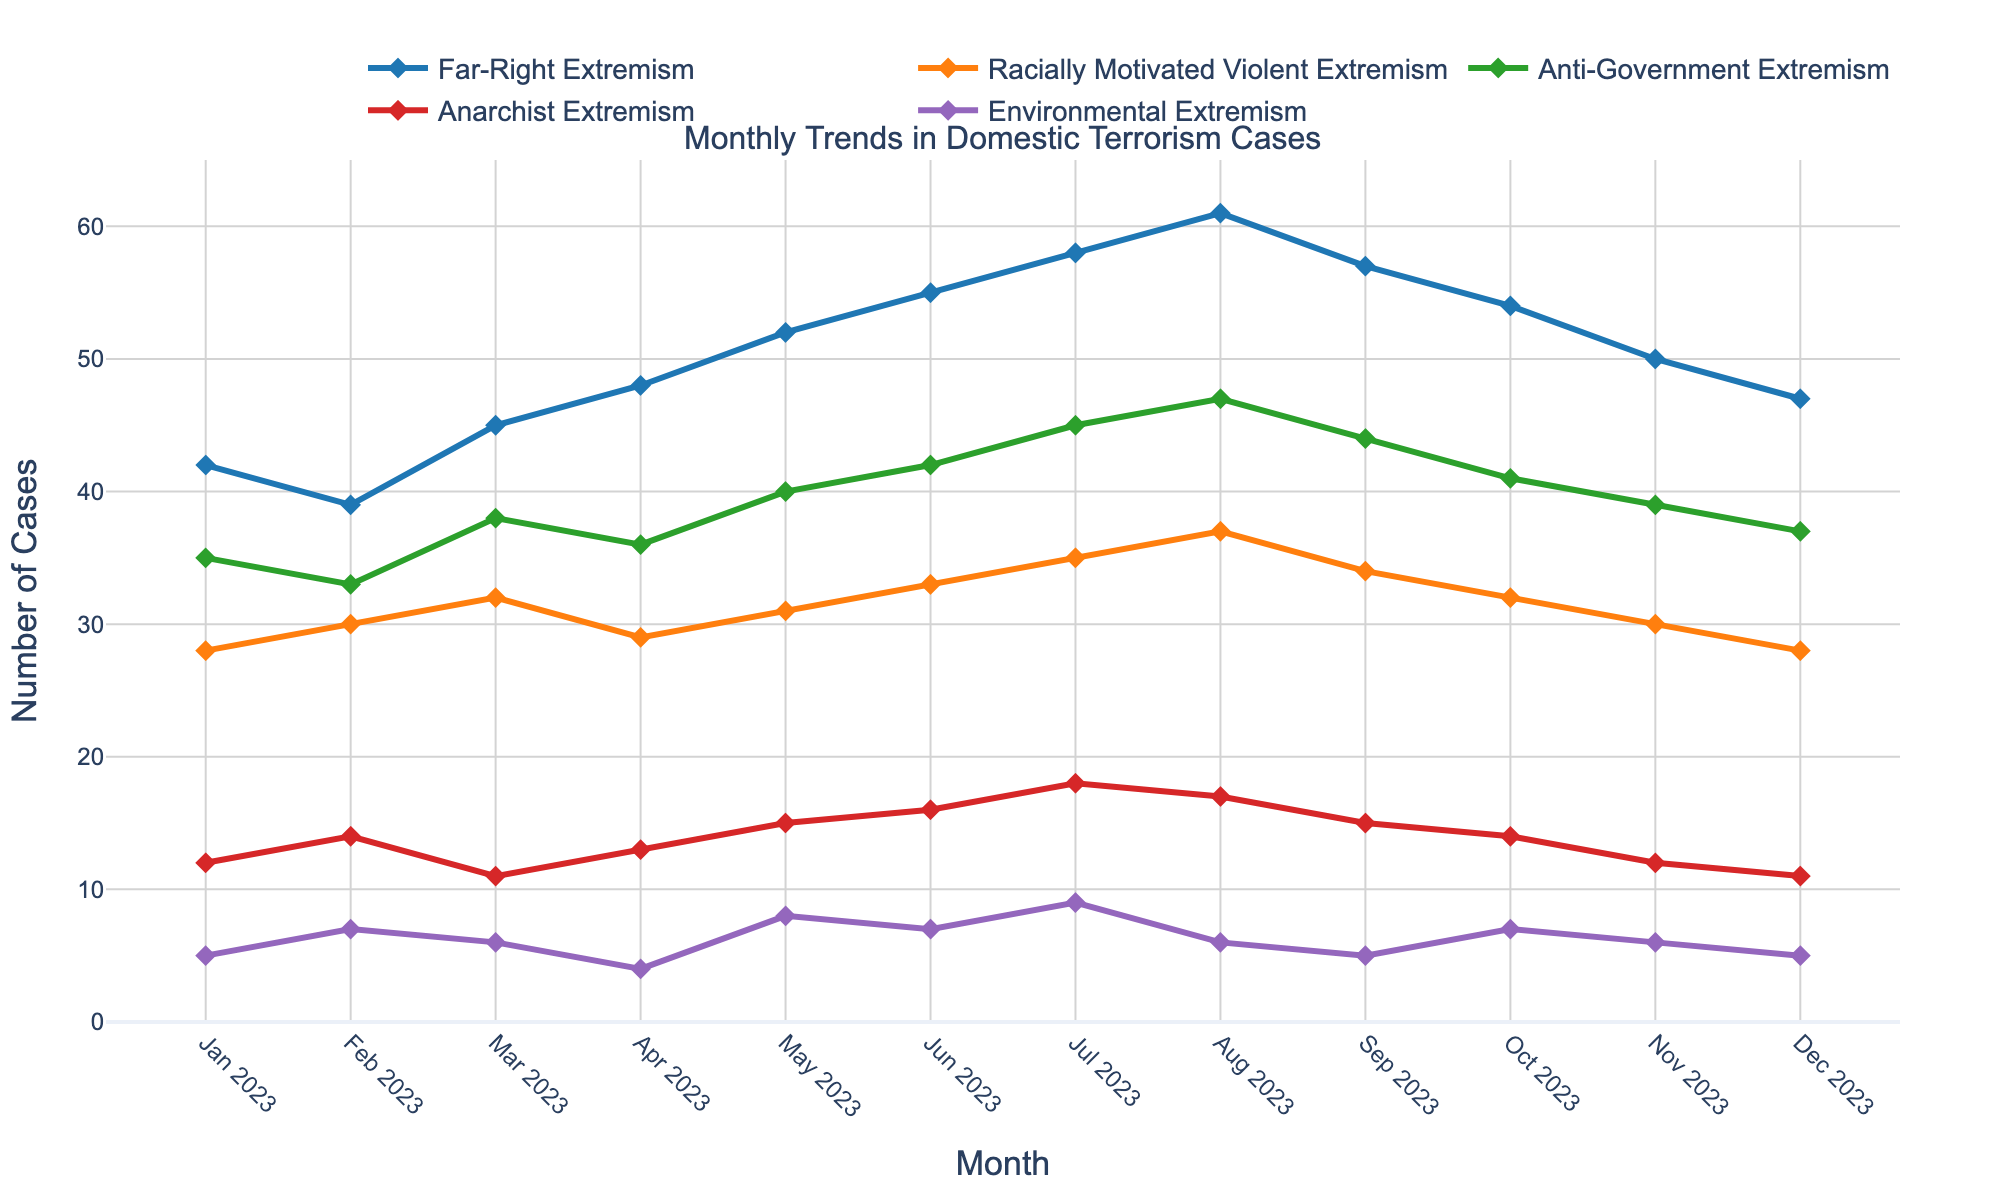What month exhibited the highest number of Far-Right Extremism cases? To find the month with the highest number of Far-Right Extremism cases, examine the peaks in the respective line. The highest value for Far-Right Extremism is 61, which occurred in August 2023.
Answer: August 2023 What is the difference in Anti-Government Extremism cases between July 2023 and October 2023? Subtract the number of Anti-Government Extremism cases in October 2023 (41) from the number in July 2023 (45). The difference is 45 - 41 = 4.
Answer: 4 Which category had the smallest number of cases in December 2023? Look for the lowest value among all the categories for December 2023. The smallest number is 5, corresponding to both Far-Right Extremism and Environmental Extremism.
Answer: Environmental Extremism How did the number of Anarchist Extremism cases change from January 2023 to December 2023? Compare the number of Anarchist Extremism cases in January 2023 (12) to December 2023 (11). The number decreased by 1.
Answer: Decreased by 1 What is the average number of Racially Motivated Violent Extremism cases throughout 2023? Sum the monthly values for Racially Motivated Violent Extremism (28 + 30 + 32 + 29 + 31 + 33 + 35 + 37 + 34 + 32 + 30 + 28) and divide by 12. The sum is 379; therefore, the average is 379 / 12 ≈ 31.58.
Answer: 31.58 Which category showed the most fluctuation over the year 2023? Fluctuation can be assessed by visually inspecting which line has the highest peaks and lowest troughs. Far-Right Extremism has substantial variance, rising from 42 to 61 and then dropping back to 47.
Answer: Far-Right Extremism In which month were Environmental Extremism cases at their highest? Find the peak value for Environmental Extremism by following its line. The highest number of cases is 9, which occurred in July 2023.
Answer: July 2023 What's the total number of Anti-Government Extremism cases for the first half of 2023? Sum the cases from January to June 2023 (35 + 33 + 38 + 36 + 40 + 42). The total is 224.
Answer: 224 Did any category have a steady increase throughout 2023 without any month-to-month decrease? Observe the line plots for consistent upward trends. Far-Right Extremism increases each month from January to August 2023 without any drops until September 2023.
Answer: Far-Right Extremism Which two categories have the most similar trends from June 2023 to December 2023? Visually compare the lines to identify similar shapes and trajectories. The trends for Racially Motivated Violent Extremism and Anti-Government Extremism are relatively similar during this period.
Answer: Racially Motivated Violent Extremism and Anti-Government Extremism 